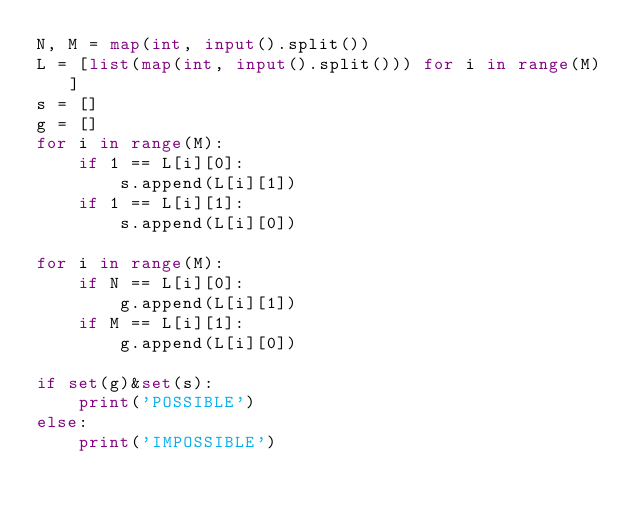Convert code to text. <code><loc_0><loc_0><loc_500><loc_500><_Python_>N, M = map(int, input().split())
L = [list(map(int, input().split())) for i in range(M)]
s = []
g = []
for i in range(M):
    if 1 == L[i][0]:
        s.append(L[i][1])
    if 1 == L[i][1]:
        s.append(L[i][0])
        
for i in range(M):
    if N == L[i][0]:
        g.append(L[i][1])
    if M == L[i][1]:
        g.append(L[i][0])
        
if set(g)&set(s):
    print('POSSIBLE')
else:
    print('IMPOSSIBLE')</code> 